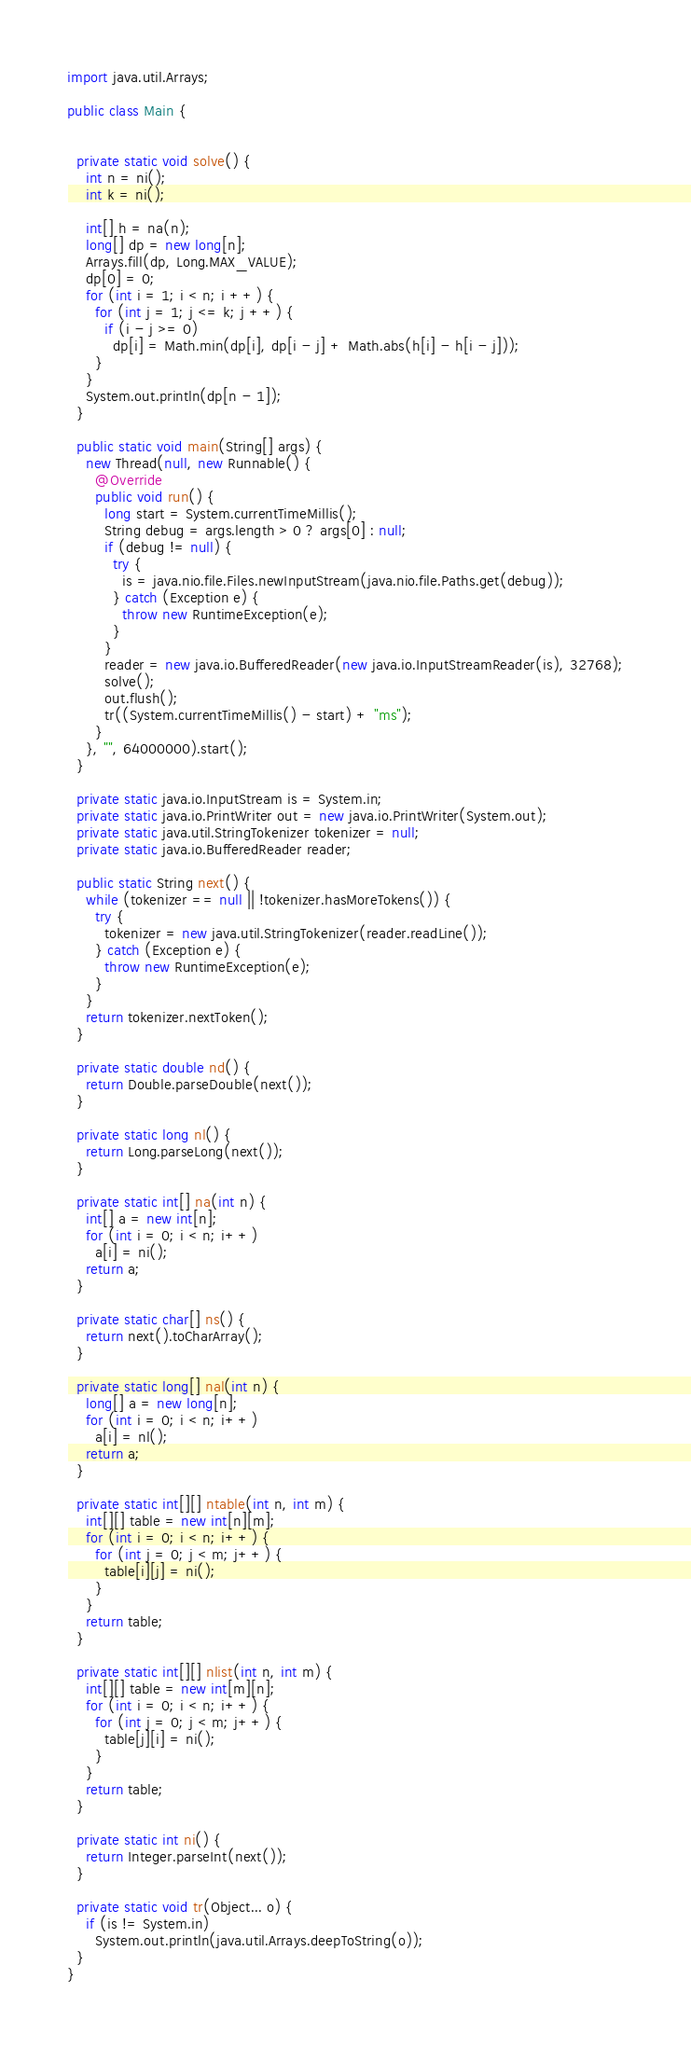<code> <loc_0><loc_0><loc_500><loc_500><_Java_>
import java.util.Arrays;

public class Main {


  private static void solve() {
    int n = ni();
    int k = ni();

    int[] h = na(n);
    long[] dp = new long[n];
    Arrays.fill(dp, Long.MAX_VALUE);
    dp[0] = 0;
    for (int i = 1; i < n; i ++) {
      for (int j = 1; j <= k; j ++) {
        if (i - j >= 0)
          dp[i] = Math.min(dp[i], dp[i - j] + Math.abs(h[i] - h[i - j]));
      }
    }
    System.out.println(dp[n - 1]);
  }

  public static void main(String[] args) {
    new Thread(null, new Runnable() {
      @Override
      public void run() {
        long start = System.currentTimeMillis();
        String debug = args.length > 0 ? args[0] : null;
        if (debug != null) {
          try {
            is = java.nio.file.Files.newInputStream(java.nio.file.Paths.get(debug));
          } catch (Exception e) {
            throw new RuntimeException(e);
          }
        }
        reader = new java.io.BufferedReader(new java.io.InputStreamReader(is), 32768);
        solve();
        out.flush();
        tr((System.currentTimeMillis() - start) + "ms");
      }
    }, "", 64000000).start();
  }

  private static java.io.InputStream is = System.in;
  private static java.io.PrintWriter out = new java.io.PrintWriter(System.out);
  private static java.util.StringTokenizer tokenizer = null;
  private static java.io.BufferedReader reader;

  public static String next() {
    while (tokenizer == null || !tokenizer.hasMoreTokens()) {
      try {
        tokenizer = new java.util.StringTokenizer(reader.readLine());
      } catch (Exception e) {
        throw new RuntimeException(e);
      }
    }
    return tokenizer.nextToken();
  }

  private static double nd() {
    return Double.parseDouble(next());
  }

  private static long nl() {
    return Long.parseLong(next());
  }

  private static int[] na(int n) {
    int[] a = new int[n];
    for (int i = 0; i < n; i++)
      a[i] = ni();
    return a;
  }

  private static char[] ns() {
    return next().toCharArray();
  }

  private static long[] nal(int n) {
    long[] a = new long[n];
    for (int i = 0; i < n; i++)
      a[i] = nl();
    return a;
  }

  private static int[][] ntable(int n, int m) {
    int[][] table = new int[n][m];
    for (int i = 0; i < n; i++) {
      for (int j = 0; j < m; j++) {
        table[i][j] = ni();
      }
    }
    return table;
  }

  private static int[][] nlist(int n, int m) {
    int[][] table = new int[m][n];
    for (int i = 0; i < n; i++) {
      for (int j = 0; j < m; j++) {
        table[j][i] = ni();
      }
    }
    return table;
  }

  private static int ni() {
    return Integer.parseInt(next());
  }

  private static void tr(Object... o) {
    if (is != System.in)
      System.out.println(java.util.Arrays.deepToString(o));
  }
}
</code> 